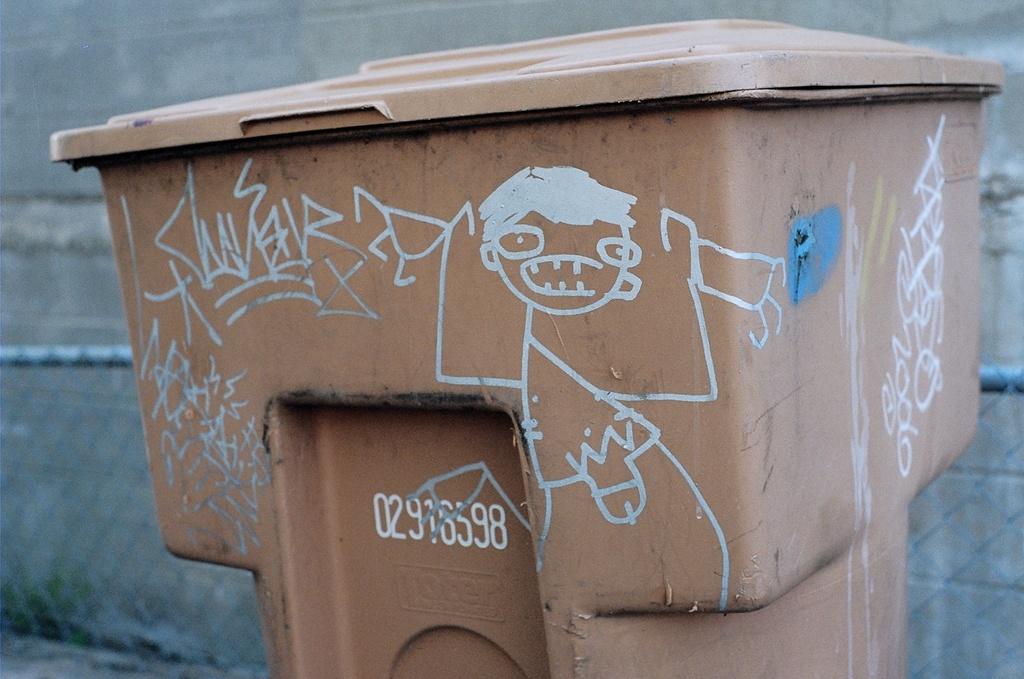What is the written under the long set of white numbers in the middle of this container?
Offer a very short reply. Toter. 